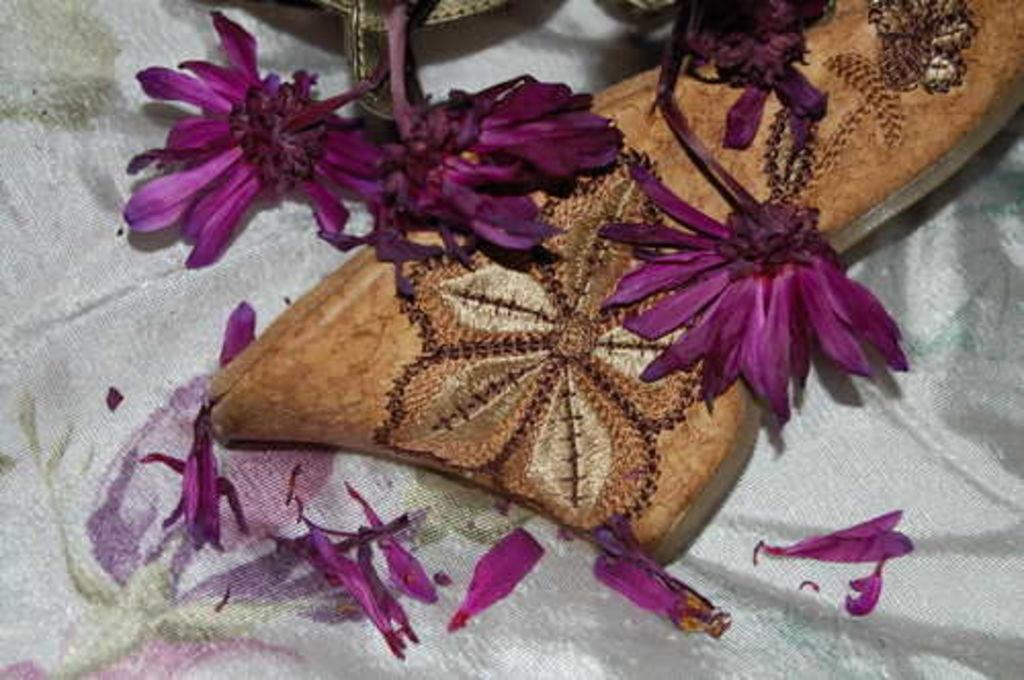What type of plants can be seen in the image? There are flowers in the image. What color are the flowers? The flowers are purple. What type of footwear is visible in the image? There is brown footwear in the image. On what is the footwear placed? The footwear is on a white cloth. What type of territory is being claimed by the flowers in the image? The flowers in the image are not claiming any territory; they are simply plants. 